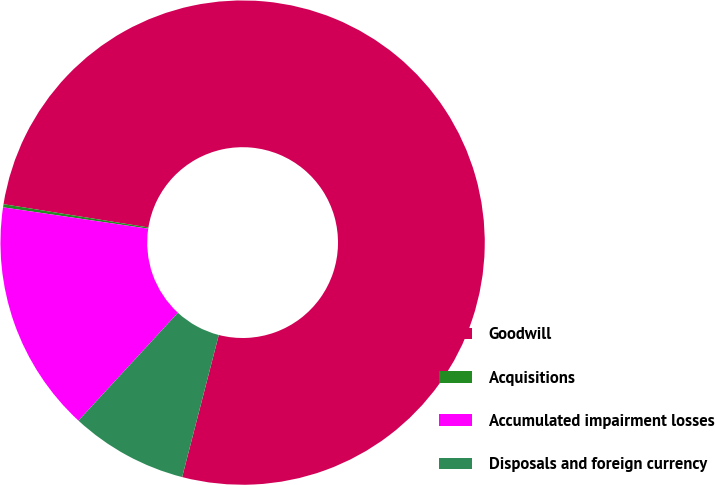<chart> <loc_0><loc_0><loc_500><loc_500><pie_chart><fcel>Goodwill<fcel>Acquisitions<fcel>Accumulated impairment losses<fcel>Disposals and foreign currency<nl><fcel>76.48%<fcel>0.21%<fcel>15.47%<fcel>7.84%<nl></chart> 